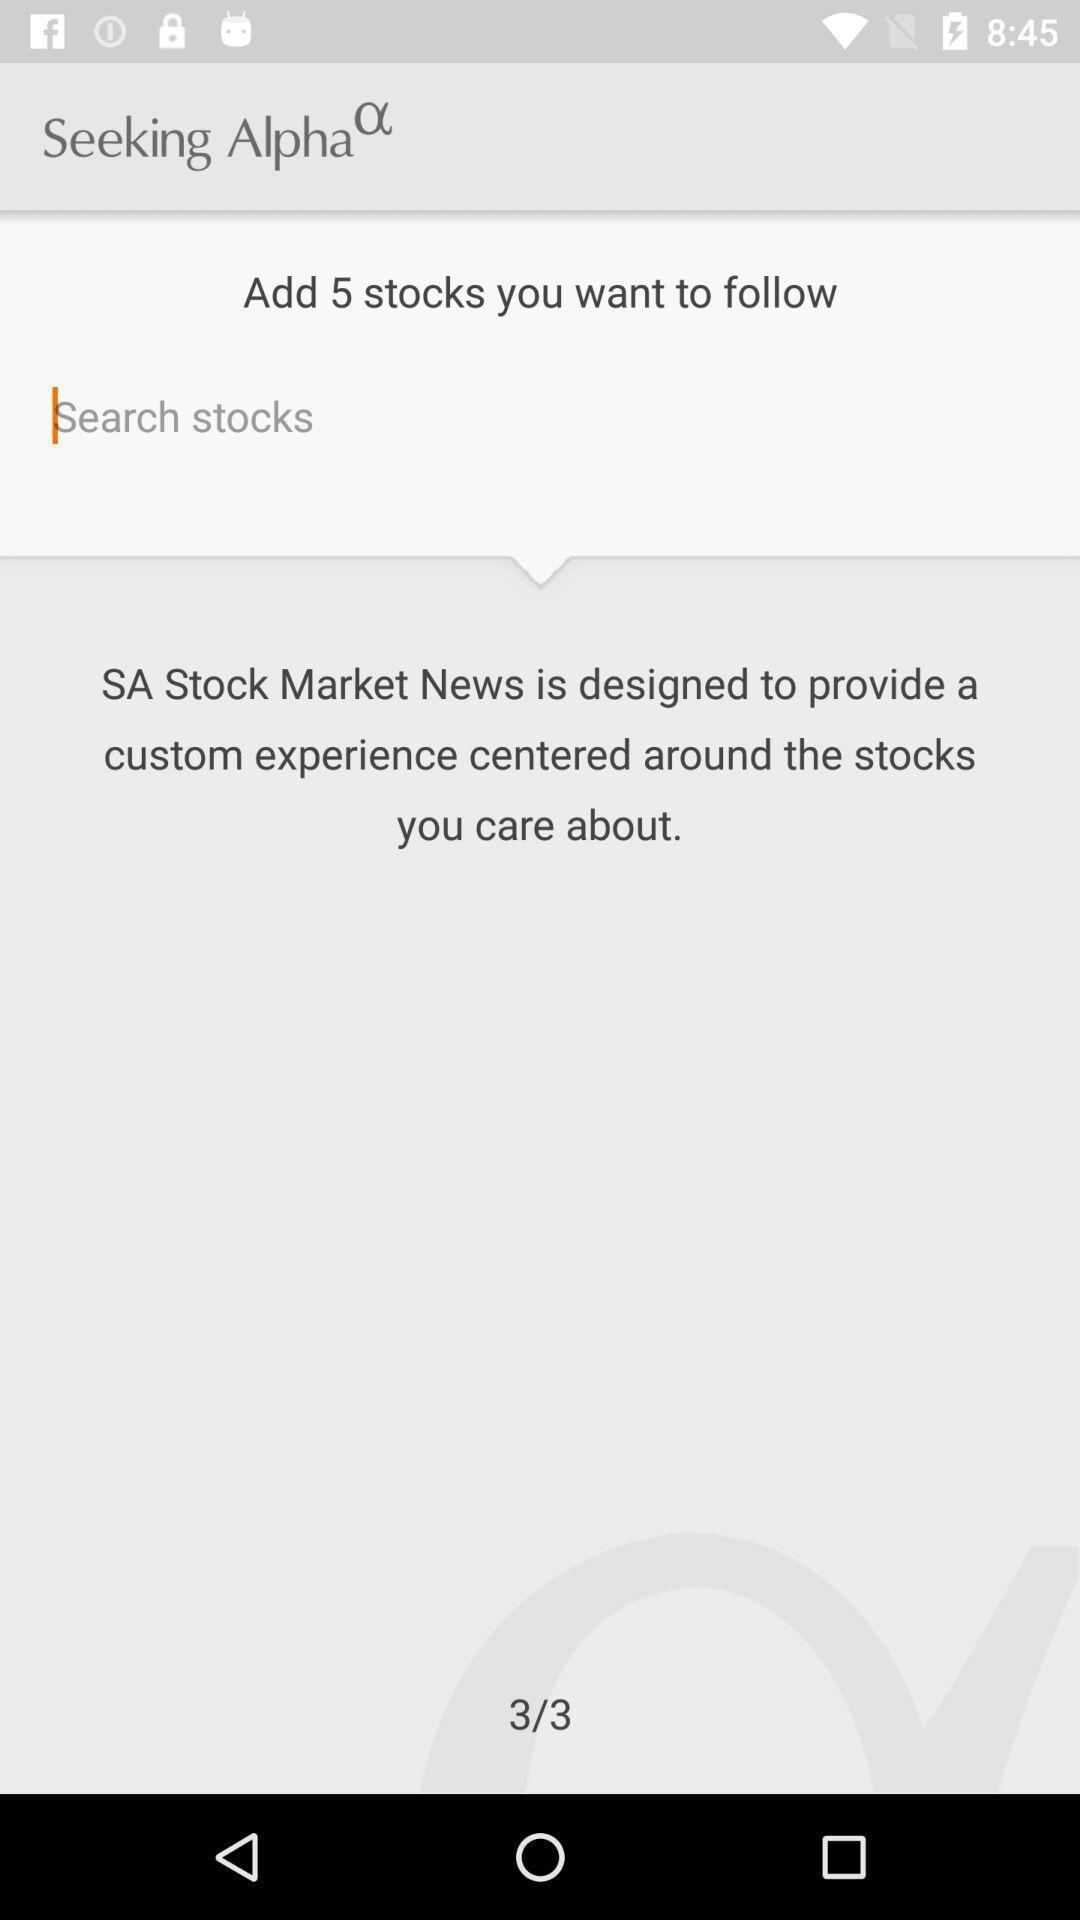Describe this image in words. Screen shows search for stocks. 